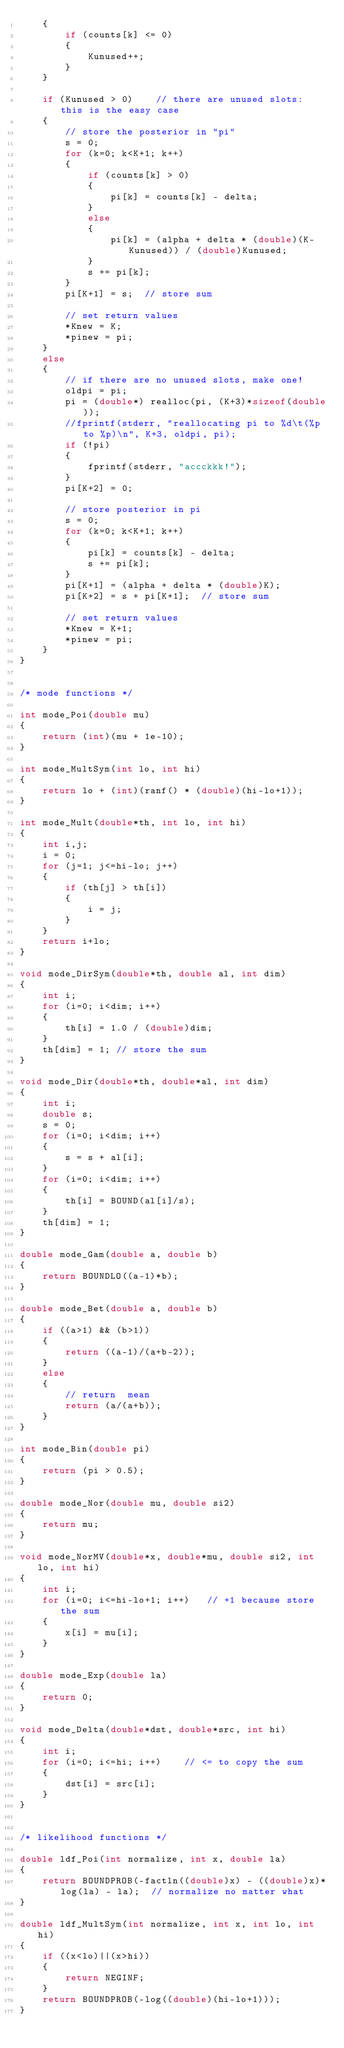<code> <loc_0><loc_0><loc_500><loc_500><_C_>    {
        if (counts[k] <= 0)
        {
            Kunused++;
        }
    }

    if (Kunused > 0)    // there are unused slots: this is the easy case
    {
        // store the posterior in "pi"
        s = 0;
        for (k=0; k<K+1; k++)
        {
            if (counts[k] > 0)
            {
                pi[k] = counts[k] - delta;
            }
            else
            {
                pi[k] = (alpha + delta * (double)(K-Kunused)) / (double)Kunused;
            }
            s += pi[k];
        }
        pi[K+1] = s;  // store sum

        // set return values
        *Knew = K;
        *pinew = pi;
    }
    else
    {
        // if there are no unused slots, make one!
        oldpi = pi;
        pi = (double*) realloc(pi, (K+3)*sizeof(double));
        //fprintf(stderr, "reallocating pi to %d\t(%p to %p)\n", K+3, oldpi, pi);
        if (!pi)
        {
            fprintf(stderr, "accckkk!");
        }
        pi[K+2] = 0;

        // store posterior in pi
        s = 0;
        for (k=0; k<K+1; k++)
        {
            pi[k] = counts[k] - delta;
            s += pi[k];
        }
        pi[K+1] = (alpha + delta * (double)K);
        pi[K+2] = s + pi[K+1];  // store sum

        // set return values
        *Knew = K+1;
        *pinew = pi;
    }
}


/* mode functions */

int mode_Poi(double mu)
{
    return (int)(mu + 1e-10);
}

int mode_MultSym(int lo, int hi)
{
    return lo + (int)(ranf() * (double)(hi-lo+1));
}

int mode_Mult(double*th, int lo, int hi)
{
    int i,j;
    i = 0;
    for (j=1; j<=hi-lo; j++)
    {
        if (th[j] > th[i])
        {
            i = j;
        }
    }
    return i+lo;
}

void mode_DirSym(double*th, double al, int dim)
{
    int i;
    for (i=0; i<dim; i++)
    {
        th[i] = 1.0 / (double)dim;
    }
    th[dim] = 1; // store the sum
}

void mode_Dir(double*th, double*al, int dim)
{
    int i;
    double s;
    s = 0;
    for (i=0; i<dim; i++)
    {
        s = s + al[i];
    }
    for (i=0; i<dim; i++)
    {
        th[i] = BOUND(al[i]/s);
    }
    th[dim] = 1;
}

double mode_Gam(double a, double b)
{
    return BOUNDLO((a-1)*b);
}

double mode_Bet(double a, double b)
{
    if ((a>1) && (b>1))
    {
        return ((a-1)/(a+b-2));
    }
    else
    {
        // return  mean
        return (a/(a+b));
    }
}

int mode_Bin(double pi)
{
    return (pi > 0.5);
}

double mode_Nor(double mu, double si2)
{
    return mu;
}

void mode_NorMV(double*x, double*mu, double si2, int lo, int hi)
{
    int i;
    for (i=0; i<=hi-lo+1; i++)   // +1 because store the sum
    {
        x[i] = mu[i];
    }
}

double mode_Exp(double la)
{
    return 0;
}

void mode_Delta(double*dst, double*src, int hi)
{
    int i;
    for (i=0; i<=hi; i++)    // <= to copy the sum
    {
        dst[i] = src[i];
    }
}


/* likelihood functions */

double ldf_Poi(int normalize, int x, double la)
{
    return BOUNDPROB(-factln((double)x) - ((double)x)*log(la) - la);  // normalize no matter what
}

double ldf_MultSym(int normalize, int x, int lo, int hi)
{
    if ((x<lo)||(x>hi))
    {
        return NEGINF;
    }
    return BOUNDPROB(-log((double)(hi-lo+1)));
}
</code> 